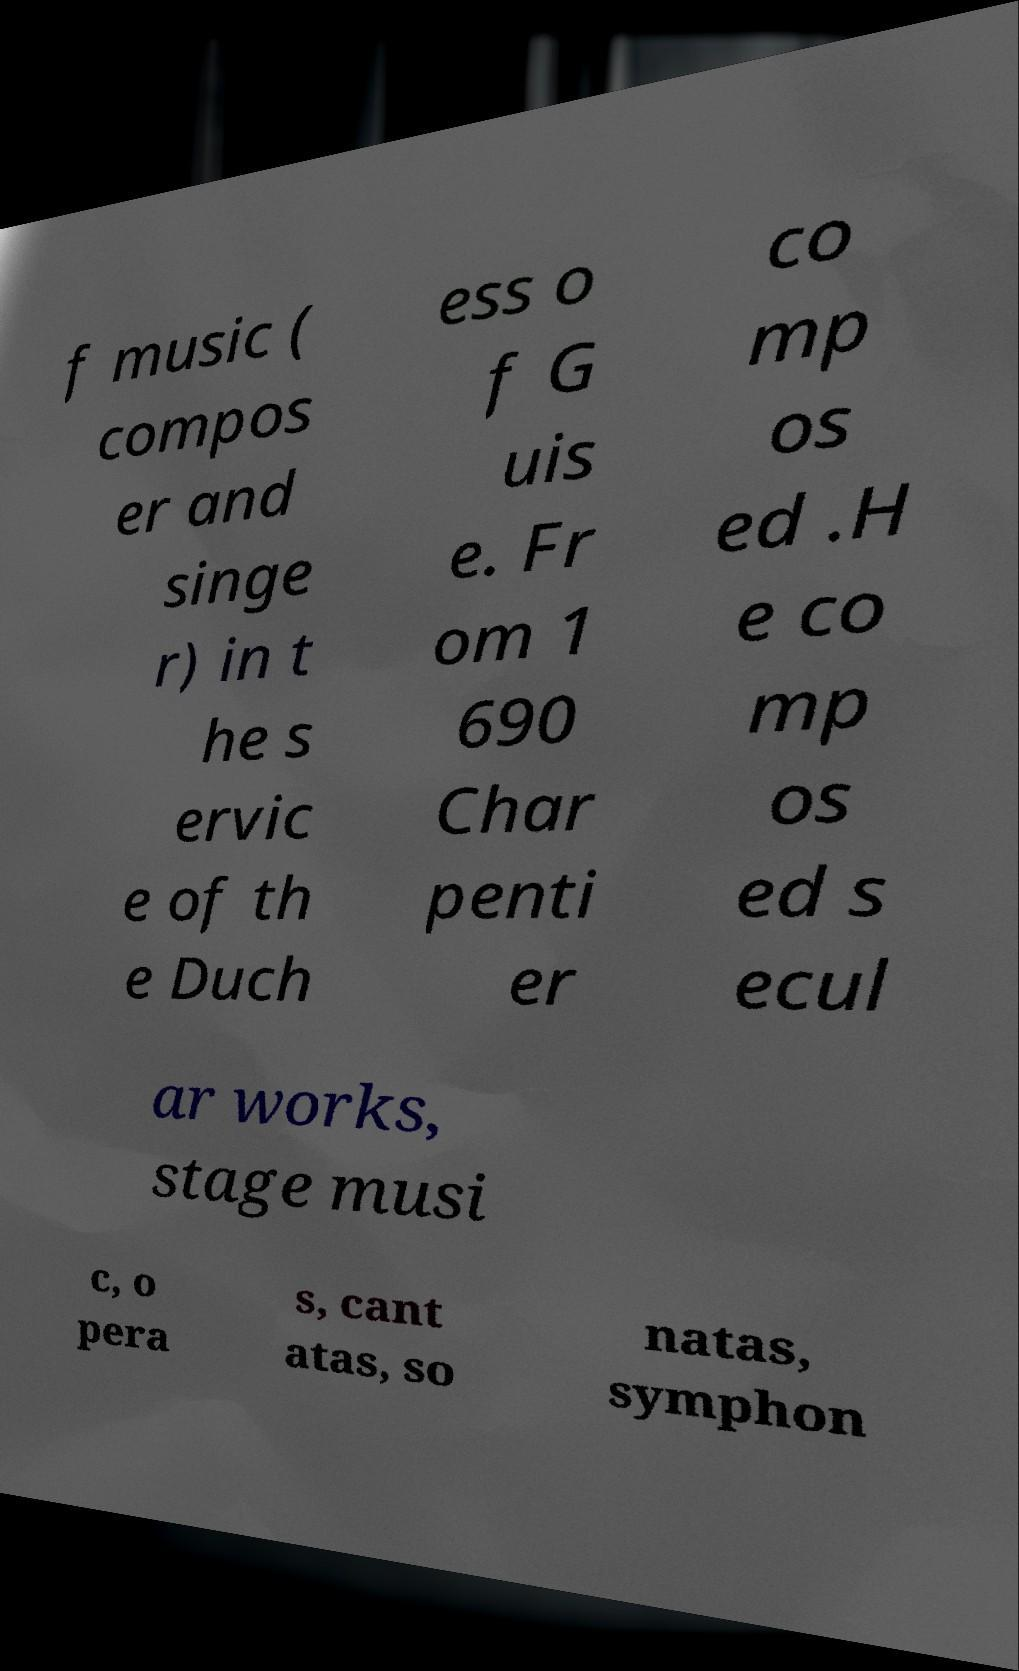Please identify and transcribe the text found in this image. f music ( compos er and singe r) in t he s ervic e of th e Duch ess o f G uis e. Fr om 1 690 Char penti er co mp os ed .H e co mp os ed s ecul ar works, stage musi c, o pera s, cant atas, so natas, symphon 